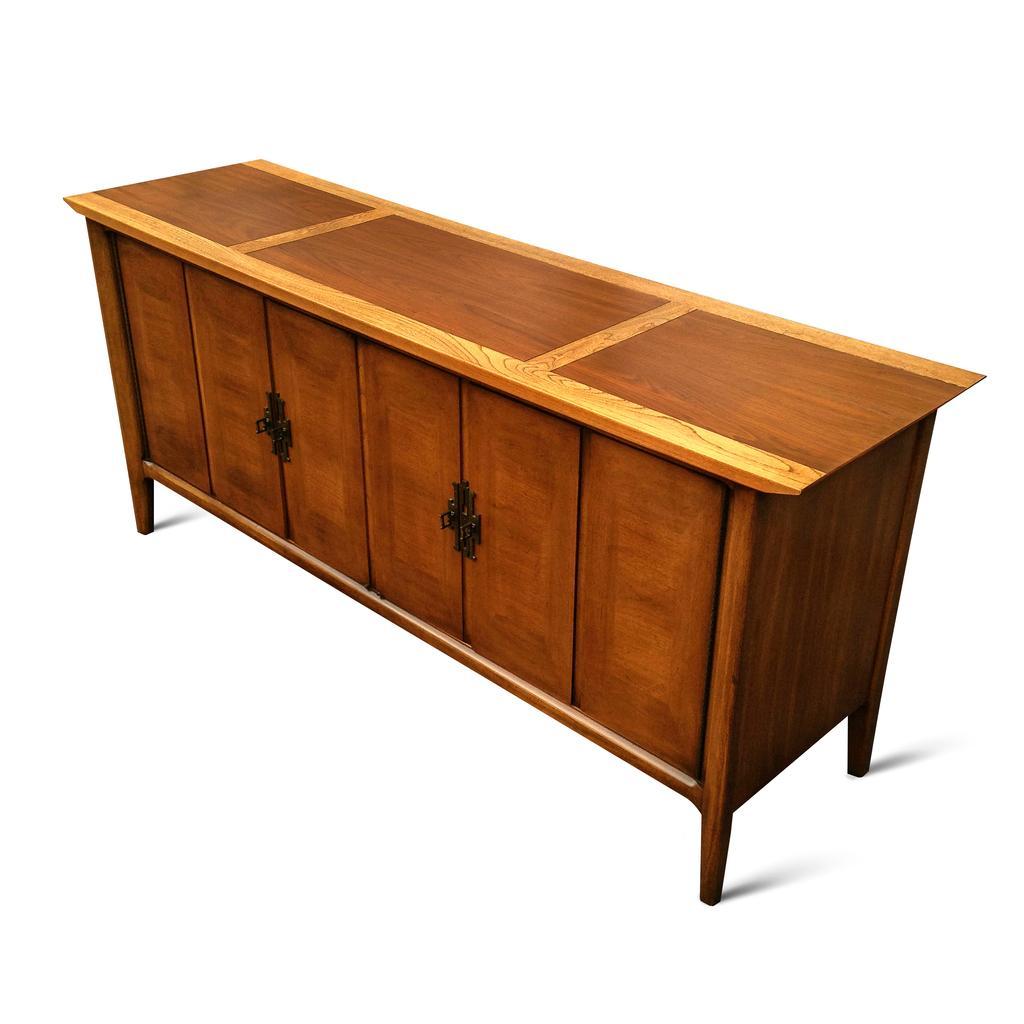Please provide a concise description of this image. In this Image I see table which is of brown in color. 